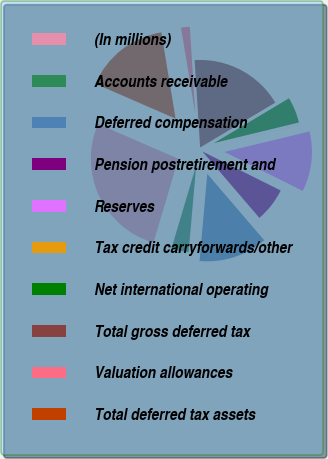Convert chart. <chart><loc_0><loc_0><loc_500><loc_500><pie_chart><fcel>(In millions)<fcel>Accounts receivable<fcel>Deferred compensation<fcel>Pension postretirement and<fcel>Reserves<fcel>Tax credit carryforwards/other<fcel>Net international operating<fcel>Total gross deferred tax<fcel>Valuation allowances<fcel>Total deferred tax assets<nl><fcel>26.94%<fcel>3.19%<fcel>12.69%<fcel>6.36%<fcel>11.11%<fcel>0.03%<fcel>4.78%<fcel>17.44%<fcel>1.61%<fcel>15.86%<nl></chart> 